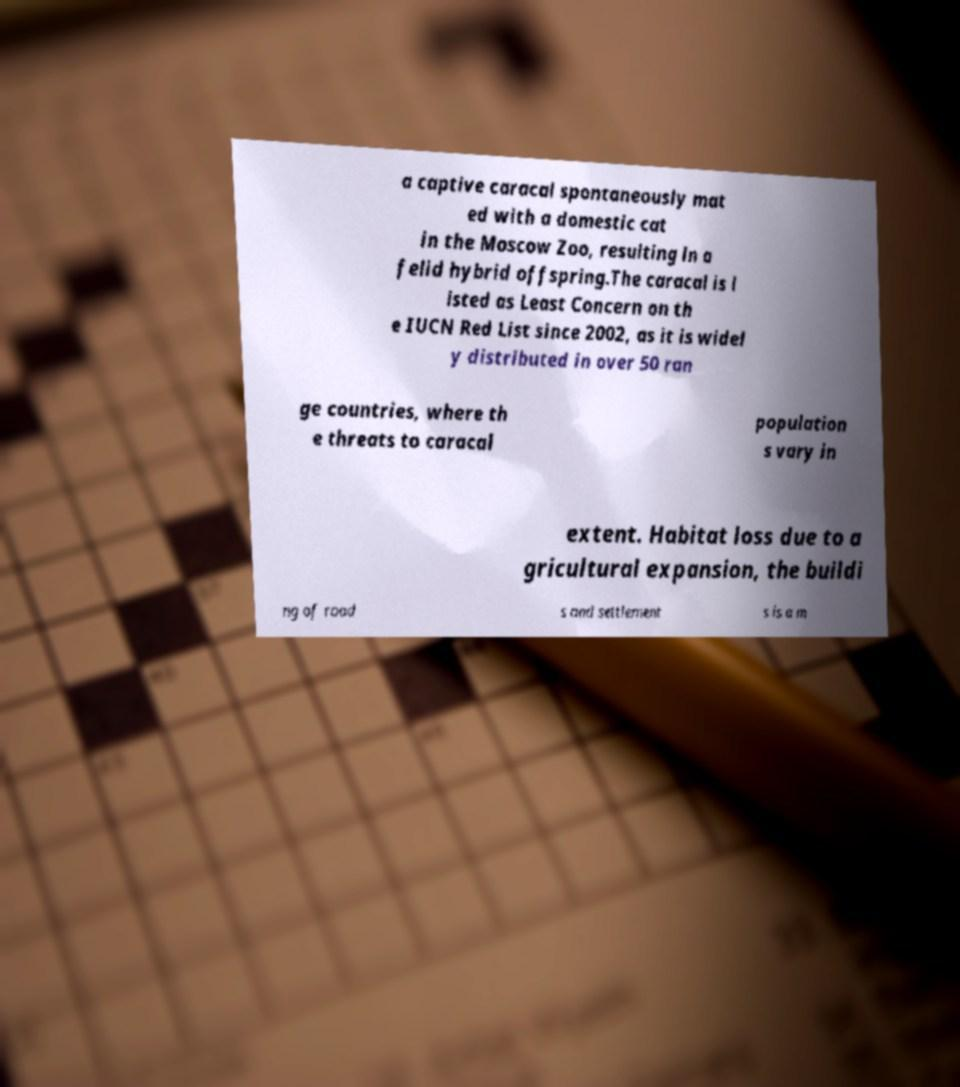Can you accurately transcribe the text from the provided image for me? a captive caracal spontaneously mat ed with a domestic cat in the Moscow Zoo, resulting in a felid hybrid offspring.The caracal is l isted as Least Concern on th e IUCN Red List since 2002, as it is widel y distributed in over 50 ran ge countries, where th e threats to caracal population s vary in extent. Habitat loss due to a gricultural expansion, the buildi ng of road s and settlement s is a m 